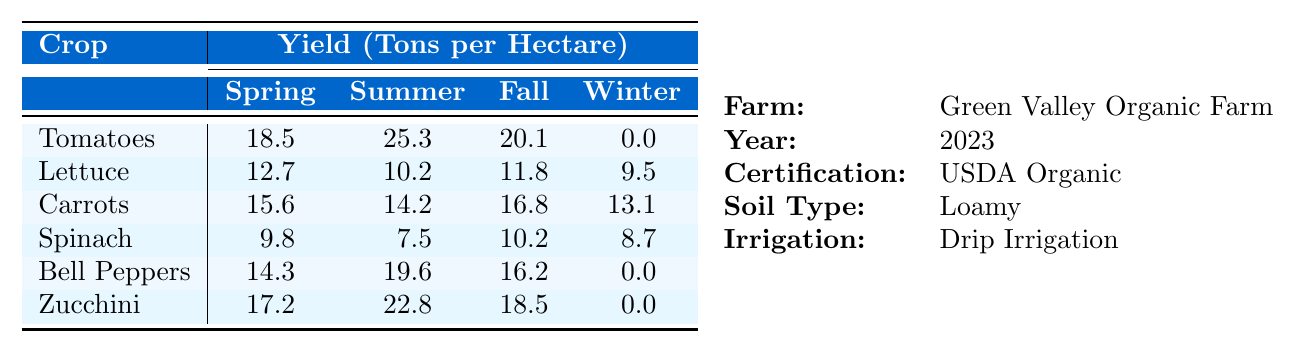What is the highest crop yield in summer? Referring to the table, the highest crop yield in the summer is for Tomatoes, which has a yield of 25.3 tons per hectare.
Answer: 25.3 tons per hectare Which crop has the lowest yield in winter? Looking at the yields for winter, both Tomatoes and Bell Peppers have a yield of 0 tons per hectare, making them the lowest for this season.
Answer: 0 tons per hectare What is the total yield of Carrots across all seasons? To find the total yield of Carrots, sum the yields from all seasons: 15.6 (Spring) + 14.2 (Summer) + 16.8 (Fall) + 13.1 (Winter) = 59.7 tons per hectare.
Answer: 59.7 tons per hectare Which crop has the highest yield difference between summer and winter? Calculate the yield difference for each crop: Tomatoes (25.3 - 0 = 25.3), Lettuce (10.2 - 9.5 = 0.7), Carrots (14.2 - 13.1 = 1.1), Spinach (7.5 - 8.7 = -1.2), Bell Peppers (19.6 - 0 = 19.6), and Zucchini (22.8 - 0 = 22.8). The largest difference is for Tomatoes at 25.3 tons per hectare.
Answer: Tomatoes Is the yield of Lettuce higher in spring or fall? Lettuce yields 12.7 tons per hectare in spring and 11.8 tons per hectare in fall. Since 12.7 is greater than 11.8, it is higher in spring.
Answer: Yes What is the average yield of all crops in summer? The yields in summer are: Tomatoes (25.3), Lettuce (10.2), Carrots (14.2), Spinach (7.5), Bell Peppers (19.6), Zucchini (22.8). The average is (25.3 + 10.2 + 14.2 + 7.5 + 19.6 + 22.8) / 6 = 16.45 tons per hectare.
Answer: 16.45 tons per hectare Which crop yields the same or more in Fall compared to Spring? Comparing the yields in both seasons: Carrots (16.8 is greater than 15.6), and Spinach (10.2 is greater than 9.8). So Carrots and Spinach yield equal or more in Fall than in Spring.
Answer: Carrots and Spinach What season produces the highest average crop yield? Calculate the average yields for each season: Spring (18.5 + 12.7 + 15.6 + 9.8 + 14.3 + 17.2) / 6 = 15.4; Summer (25.3 + 10.2 + 14.2 + 7.5 + 19.6 + 22.8) / 6 = 17.1; Fall (20.1 + 11.8 + 16.8 + 10.2 + 16.2 + 18.5) / 6 = 16.3; Winter (0 + 9.5 + 13.1 + 8.7 + 0 + 0) / 6 = 3.79. Summer has the highest average at 17.1 tons per hectare.
Answer: Summer How many crops yield zero in winter? In winter, Tomatoes and Bell Peppers yield 0 tons per hectare, hence there are 2 crops that have a yield of zero in winter.
Answer: 2 crops What is the total yield of Zucchini and Tomatoes in Spring? For Spring, Zucchini has a yield of 17.2 tons per hectare and Tomatoes have 18.5 tons per hectare. Adding these gives 17.2 + 18.5 = 35.7 tons per hectare.
Answer: 35.7 tons per hectare 